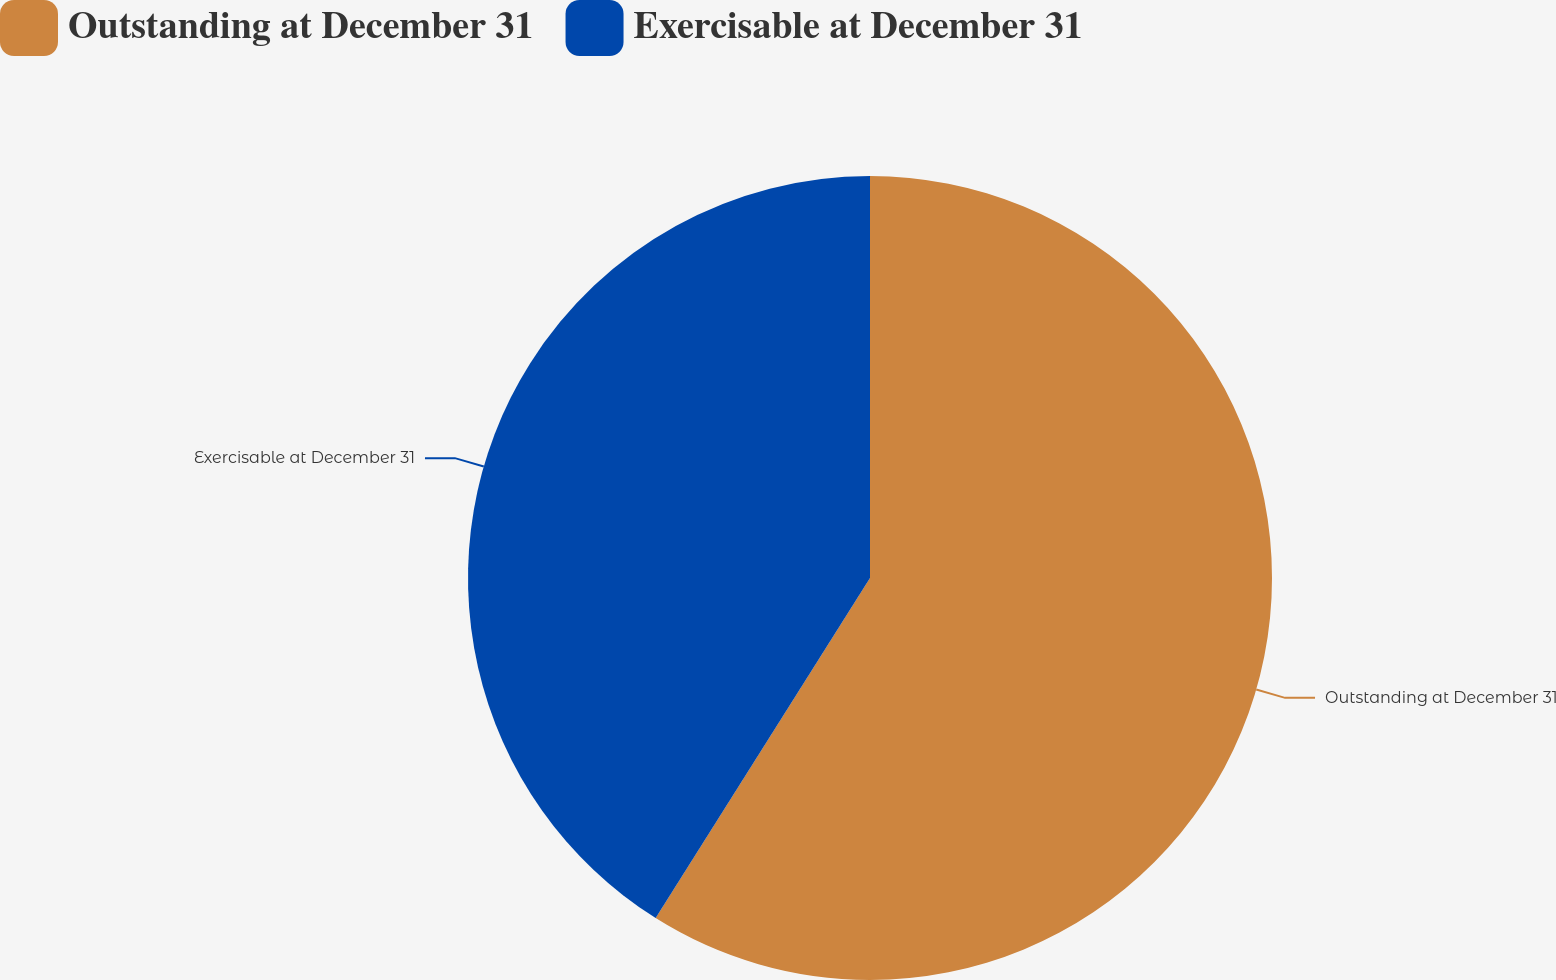<chart> <loc_0><loc_0><loc_500><loc_500><pie_chart><fcel>Outstanding at December 31<fcel>Exercisable at December 31<nl><fcel>58.95%<fcel>41.05%<nl></chart> 